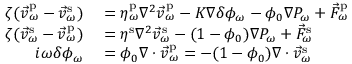<formula> <loc_0><loc_0><loc_500><loc_500>\begin{array} { r l } { \zeta ( \vec { v } _ { \omega } ^ { p } - \vec { v } _ { \omega } ^ { s } ) } & = \eta _ { \omega } ^ { p } \nabla ^ { 2 } \vec { v } _ { \omega } ^ { p } - K \nabla \delta \phi _ { \omega } - \phi _ { 0 } \nabla P _ { \omega } + \vec { F } _ { \omega } ^ { p } } \\ { \zeta ( \vec { v } _ { \omega } ^ { s } - \vec { v } _ { \omega } ^ { p } ) } & = \eta ^ { s } \nabla ^ { 2 } \vec { v } _ { \omega } ^ { s } - ( 1 - \phi _ { 0 } ) \nabla P _ { \omega } + \vec { F } _ { \omega } ^ { s } } \\ { i \omega \delta \phi _ { \omega } } & = \phi _ { 0 } \nabla \cdot \vec { v } _ { \omega } ^ { p } = - ( 1 - \phi _ { 0 } ) \nabla \cdot \vec { v } _ { \omega } ^ { s } } \end{array}</formula> 